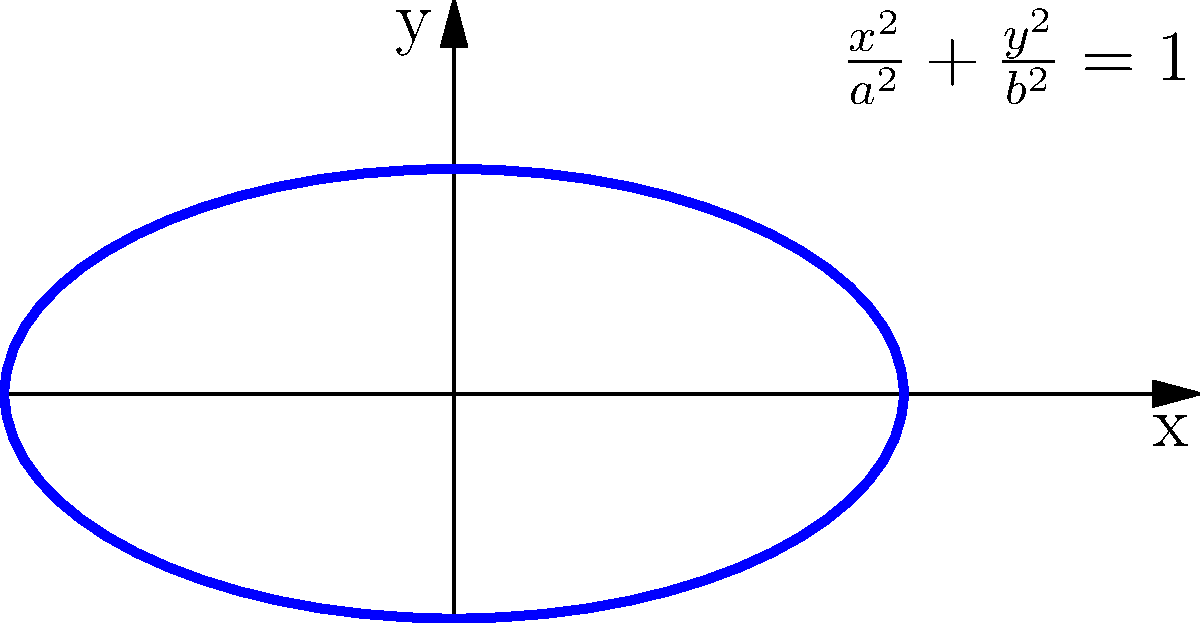Given the general equation $Ax^2 + By^2 + Cxy + Dx + Ey + F = 0$, where $A$, $B$, $C$, $D$, $E$, and $F$ are constants and $A$ and $B$ are not both zero, how would you determine if this equation represents an ellipse? Provide a specific condition involving the coefficients. To determine if the given general equation represents an ellipse, we need to follow these steps:

1) First, recall that for an ellipse, the coefficients of $x^2$ and $y^2$ must have the same sign, and the coefficient of the $xy$ term must be zero or can be eliminated through rotation.

2) The condition for an ellipse involves the discriminant of the quadratic terms. The discriminant is defined as:

   $\Delta = B^2 - 4AC$

3) For an ellipse, we must have:

   $\Delta = B^2 - 4AC < 0$

4) This condition ensures that:
   a) The coefficients $A$ and $C$ have the same sign (both positive or both negative).
   b) If there's an $xy$ term (i.e., $B \neq 0$), its coefficient is not large enough to change the nature of the conic section.

5) It's worth noting that this condition alone is not sufficient to guarantee an ellipse. We also need to ensure that the equation represents a real, non-degenerate conic section. This involves checking that the determinant of the matrix of coefficients is non-zero.

6) However, for the purposes of distinguishing an ellipse from other conic sections (hyperbola and parabola), the condition $B^2 - 4AC < 0$ is sufficient.

By using this condition, we can quickly identify whether a given equation potentially represents an ellipse, which is crucial when debugging or validating conic section classifications in data science applications.
Answer: $B^2 - 4AC < 0$ 